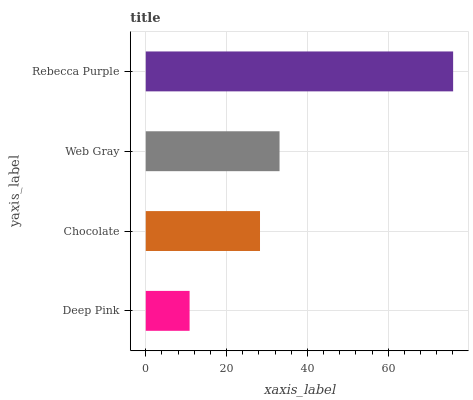Is Deep Pink the minimum?
Answer yes or no. Yes. Is Rebecca Purple the maximum?
Answer yes or no. Yes. Is Chocolate the minimum?
Answer yes or no. No. Is Chocolate the maximum?
Answer yes or no. No. Is Chocolate greater than Deep Pink?
Answer yes or no. Yes. Is Deep Pink less than Chocolate?
Answer yes or no. Yes. Is Deep Pink greater than Chocolate?
Answer yes or no. No. Is Chocolate less than Deep Pink?
Answer yes or no. No. Is Web Gray the high median?
Answer yes or no. Yes. Is Chocolate the low median?
Answer yes or no. Yes. Is Deep Pink the high median?
Answer yes or no. No. Is Deep Pink the low median?
Answer yes or no. No. 